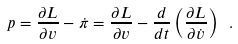<formula> <loc_0><loc_0><loc_500><loc_500>p = \frac { \partial L } { \partial v } - \dot { \pi } = \frac { \partial L } { \partial v } - \frac { d } { d t } \left ( \frac { \partial L } { \partial \dot { v } } \right ) \ .</formula> 